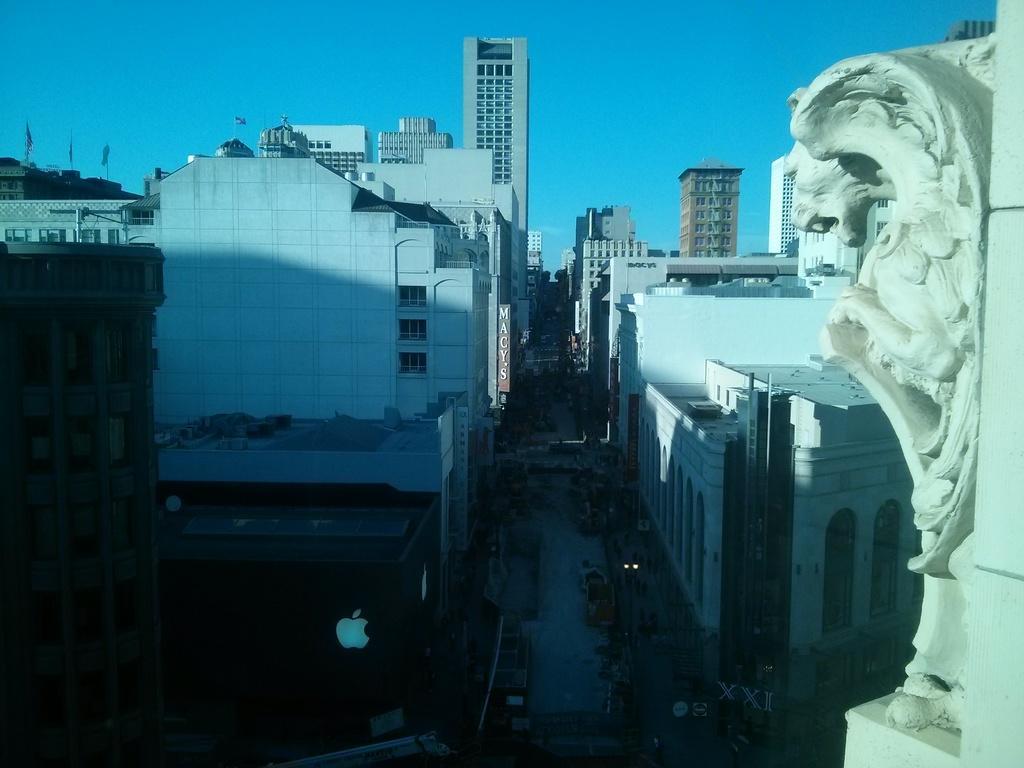Please provide a concise description of this image. In this image I can see buildings, between the buildings I can see a road, at the top I can see the sky, on the right side I can see a sculpture attached to the wall. 